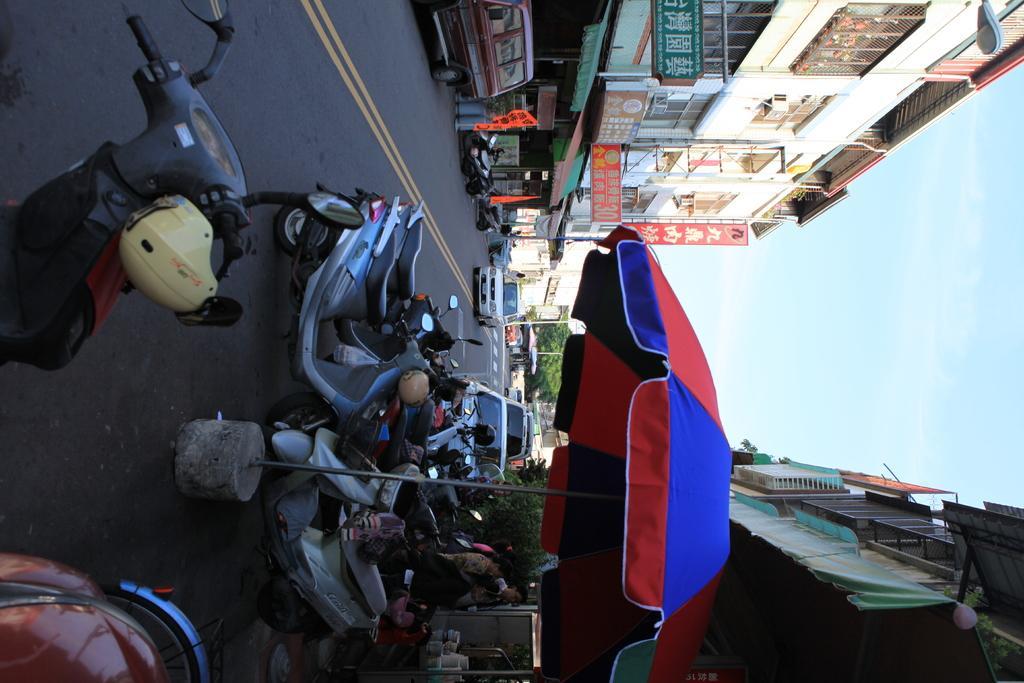Please provide a concise description of this image. In this image I can see the road, few vehicles on the road, an umbrella which is red and blue in color, few persons standing and few buildings on both sides of the road. In the background I can see the sky. 